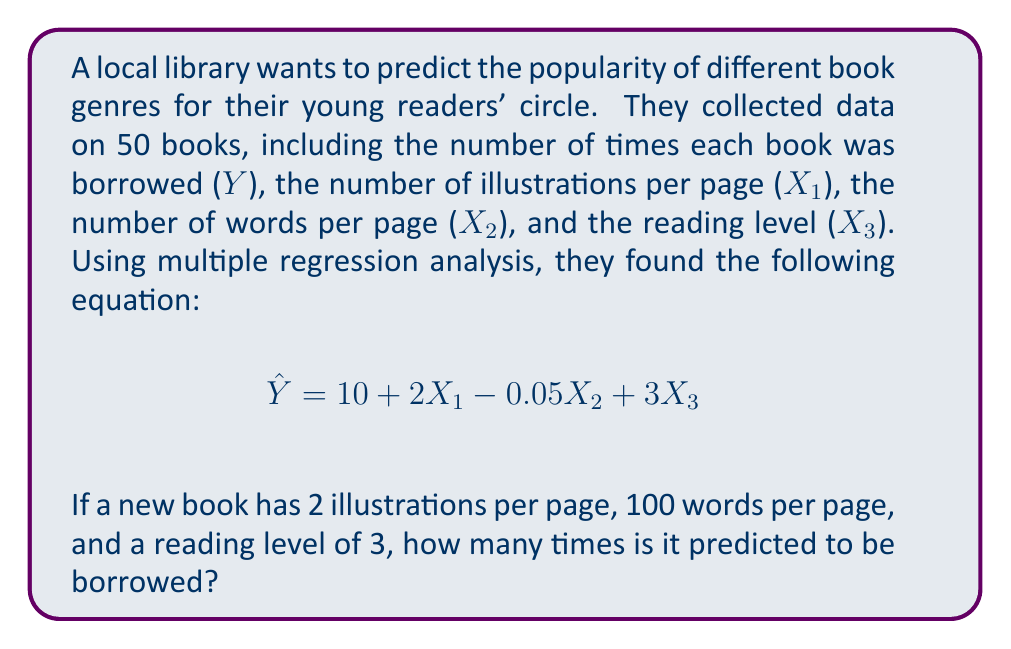Give your solution to this math problem. To solve this problem, we'll follow these steps:

1. Identify the given multiple regression equation:
   $$\hat{Y} = 10 + 2X₁ - 0.05X₂ + 3X₃$$

2. Identify the values for each predictor variable:
   - X₁ (illustrations per page) = 2
   - X₂ (words per page) = 100
   - X₃ (reading level) = 3

3. Substitute these values into the equation:
   $$\hat{Y} = 10 + 2(2) - 0.05(100) + 3(3)$$

4. Solve the equation:
   $$\hat{Y} = 10 + 4 - 5 + 9$$
   $$\hat{Y} = 18$$

Therefore, the predicted number of times the new book will be borrowed is 18.
Answer: 18 times 